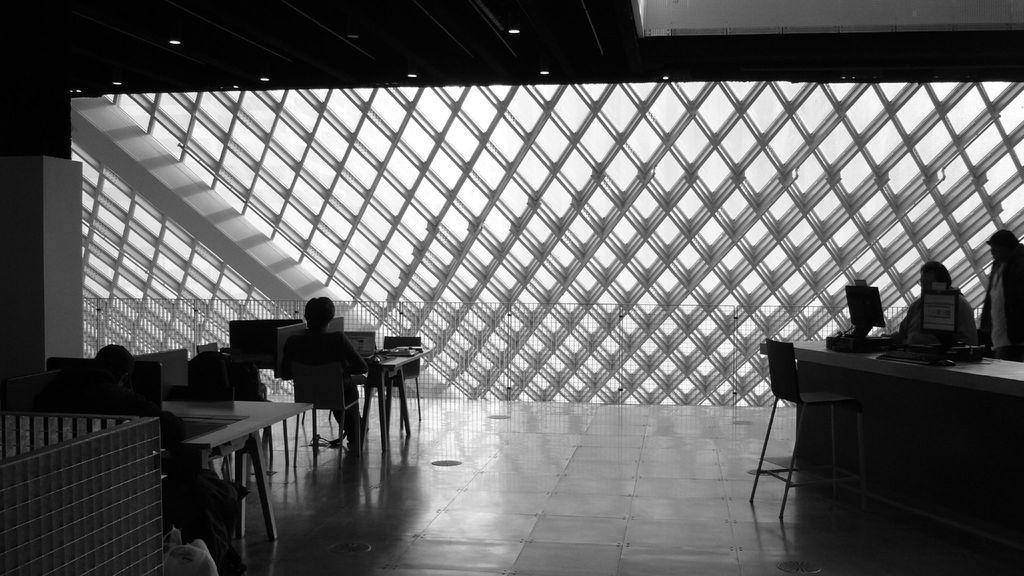How would you summarize this image in a sentence or two? This image is taken from inside. In this image we can see there are a few tables and chairs are arranged, there are a few people sitting on the chairs in front of the table. On the right side of the image there are two people standing in front of the table with monitors and some other objects on top of it. In the background there is a wall with glass. At the top of the image there is a ceiling with lights. 